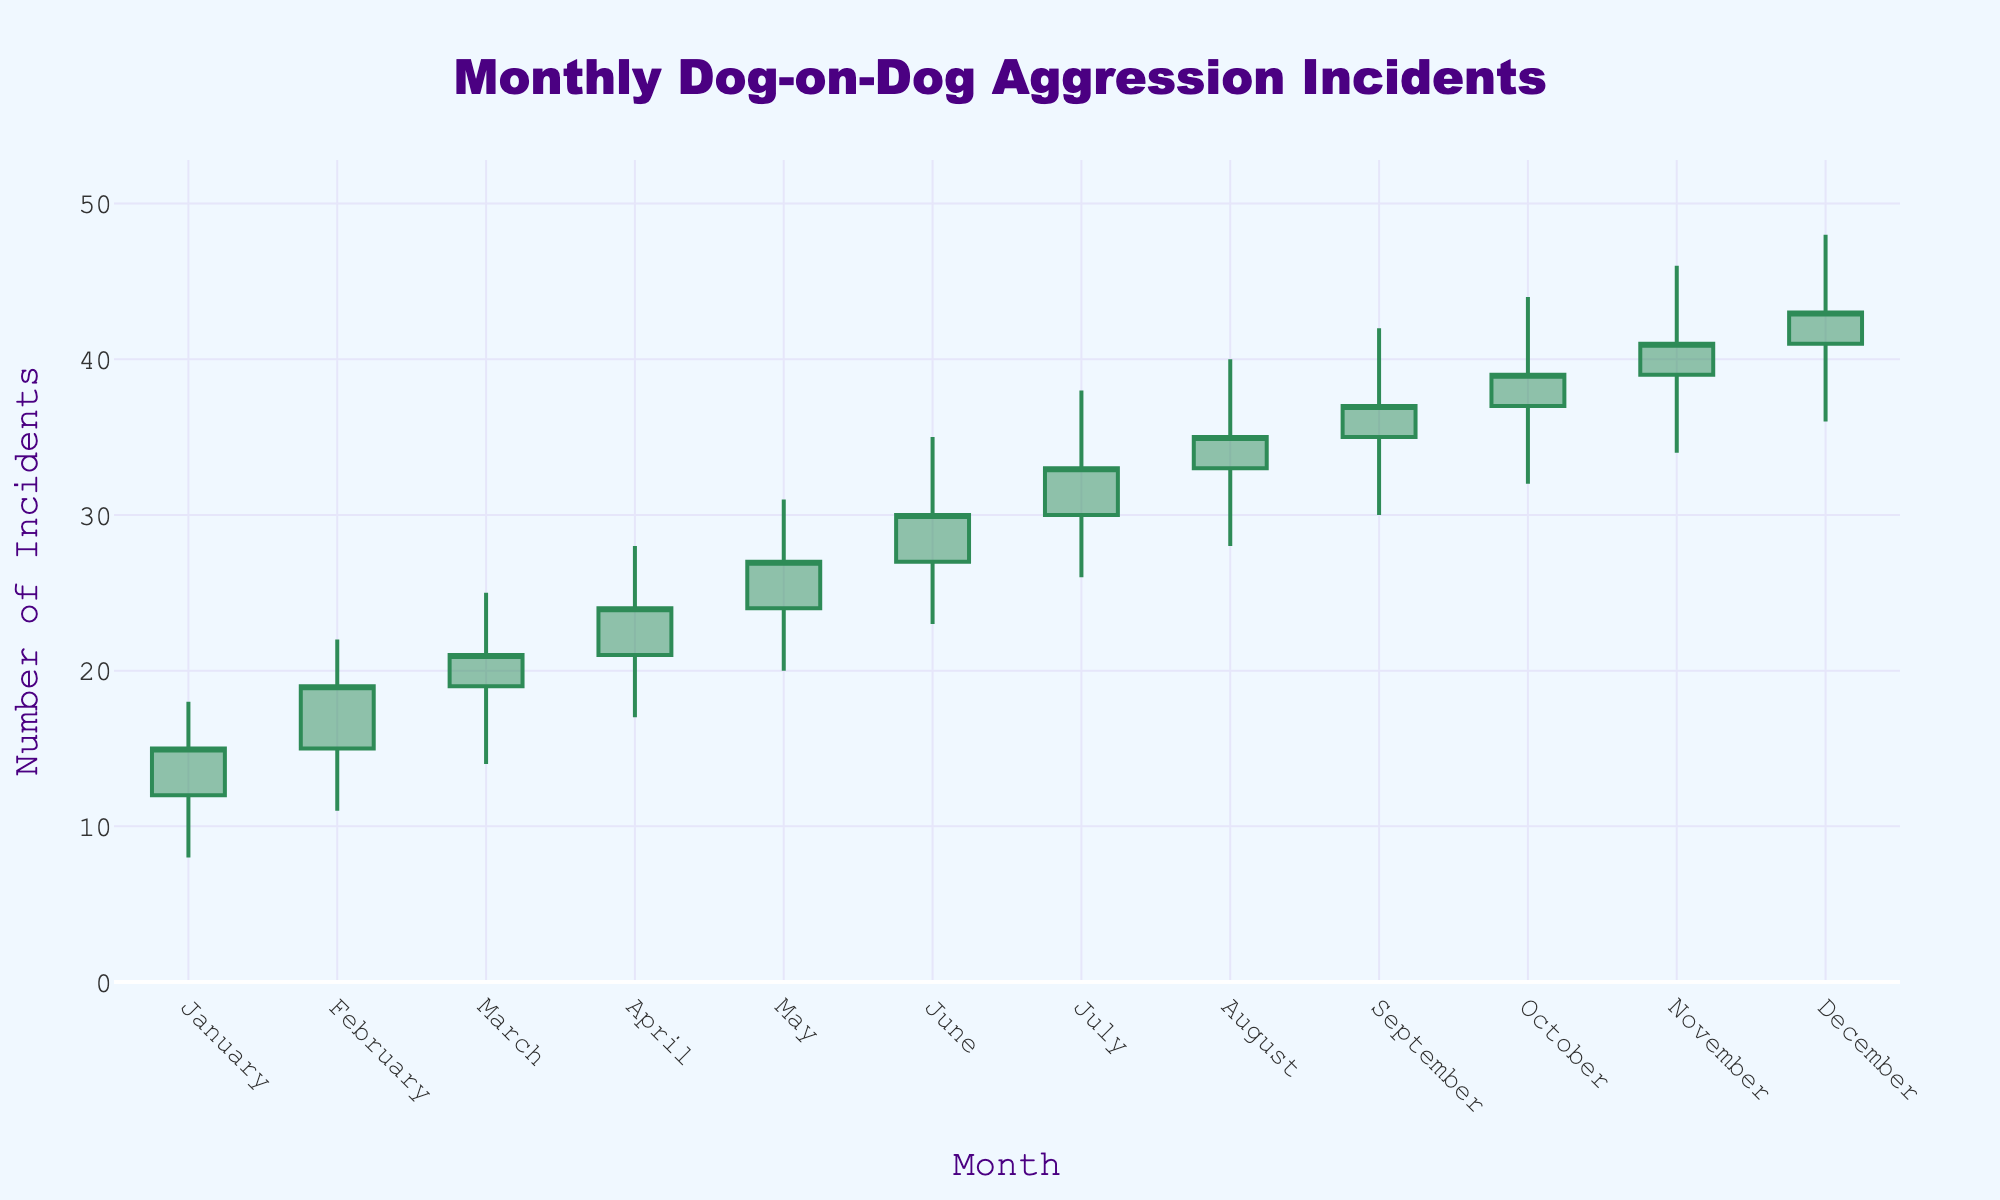What is the title of the figure? The title is typically displayed prominently at the top of the figure. In this case, it is mentioned in the settings.
Answer: Monthly Dog-on-Dog Aggression Incidents What is the highest value reported in the chart, and in which month did it occur? The high values are marked by the highest points in each candlestick. February through December have the highest value of 48 incidents in December.
Answer: December, 48 Which month observed the lowest number of incidents at its lowest point? Each candlestick has a lower wick representing the lowest point. January’s candlestick shows the lowest low with 8 incidents.
Answer: January, 8 How many incidents were reported at the end of March? The closing number of incidents each month is represented by the upper part of the candlestick body. The closing value for March is 21.
Answer: 21 Compare the number of incidents in the month of June and July. Which month had a higher closing value? Look at the closing values of the candlesticks for June and July. July has a higher closing value (33) than June (30).
Answer: July What is the average number of incidents reported as the opening value for the first three months? The opening values for January, February, and March are 12, 15, and 19, respectively. Add these values and divide by 3: (12 + 15 + 19) / 3 = 15.33
Answer: 15.33 What is the range of incidents reported in October, and how is it calculated? The range is the difference between the highest and lowest values in October, which are 44 and 32, respectively. The range is calculated as 44 - 32 = 12.
Answer: 12 Which month had the most significant increase from its opening to closing value? Subtract the opening value from the closing value for each month and find the maximum difference. February has the most significant increase of 4 (19 - 15).
Answer: February What trend do you notice in the closing values of each month from January to December? Observe the closing values plotted over time. The closing values show a general upward trend, consistently increasing each month.
Answer: Upward trend Is there any month where the opening and closing values are the same? Check each candlestick's opening and closing values. None of the months have identical opening and closing values.
Answer: No 